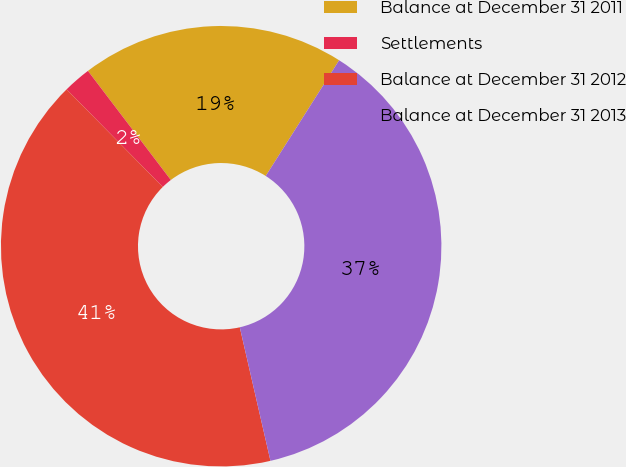Convert chart to OTSL. <chart><loc_0><loc_0><loc_500><loc_500><pie_chart><fcel>Balance at December 31 2011<fcel>Settlements<fcel>Balance at December 31 2012<fcel>Balance at December 31 2013<nl><fcel>19.34%<fcel>2.04%<fcel>41.21%<fcel>37.41%<nl></chart> 